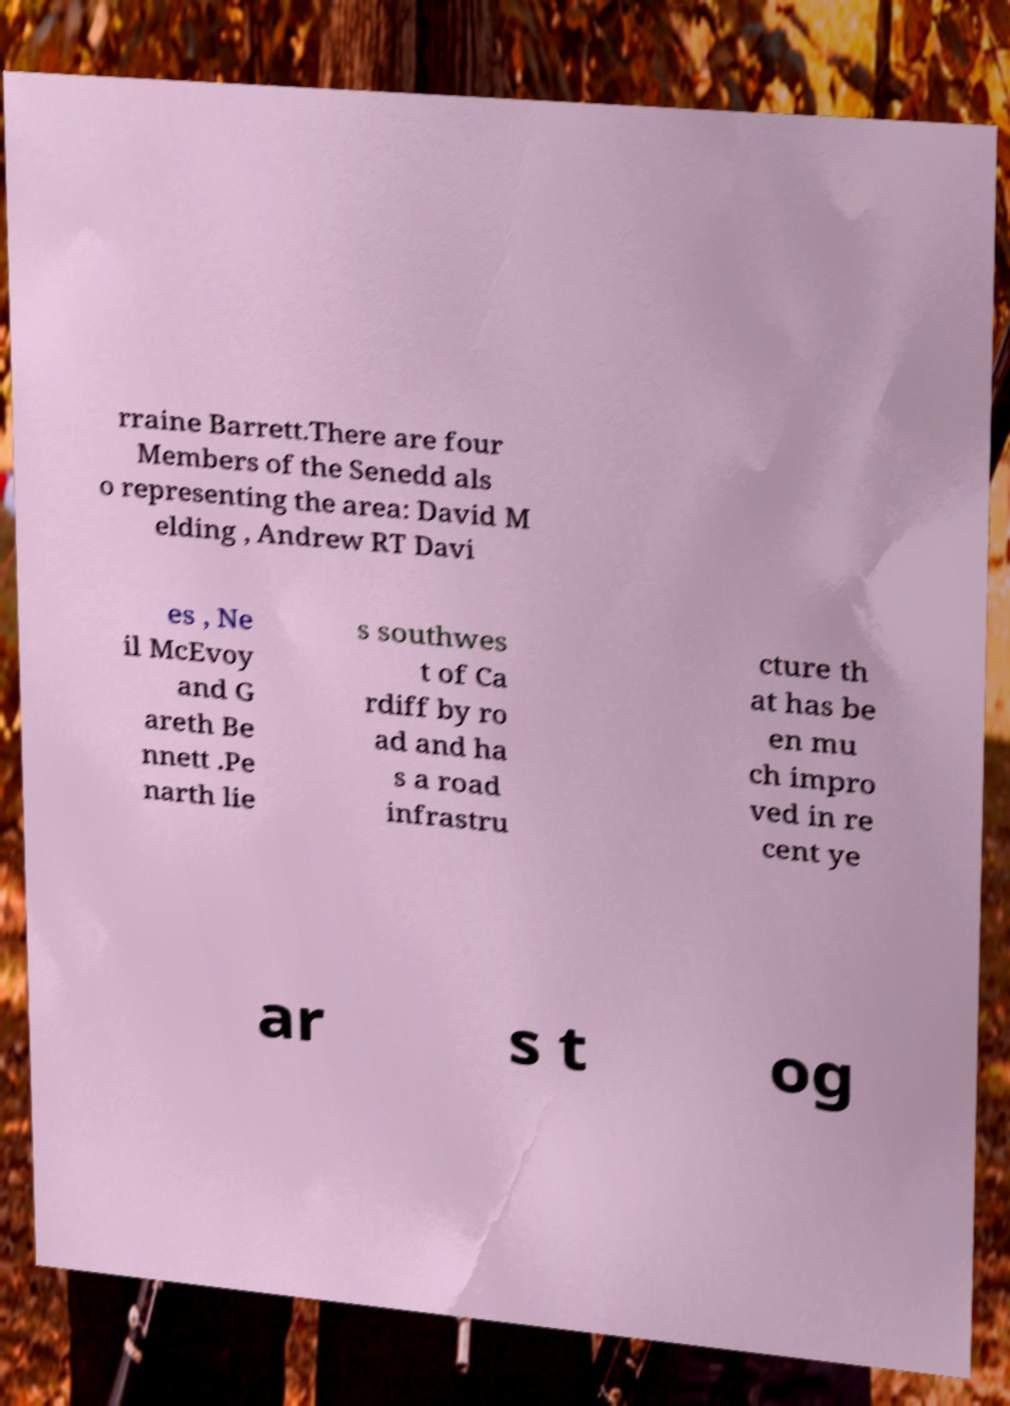For documentation purposes, I need the text within this image transcribed. Could you provide that? rraine Barrett.There are four Members of the Senedd als o representing the area: David M elding , Andrew RT Davi es , Ne il McEvoy and G areth Be nnett .Pe narth lie s southwes t of Ca rdiff by ro ad and ha s a road infrastru cture th at has be en mu ch impro ved in re cent ye ar s t og 